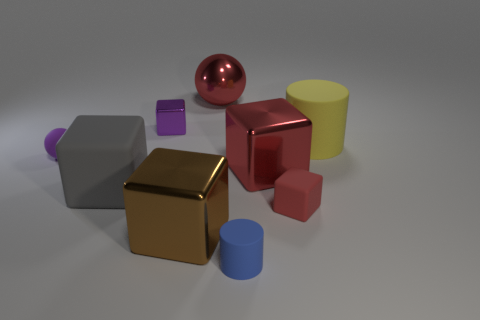Subtract all purple cubes. How many cubes are left? 4 Subtract all gray blocks. How many blocks are left? 4 Subtract all cyan cubes. Subtract all cyan spheres. How many cubes are left? 5 Subtract all balls. How many objects are left? 7 Subtract 0 cyan cylinders. How many objects are left? 9 Subtract all large gray objects. Subtract all big red objects. How many objects are left? 6 Add 4 large red metallic balls. How many large red metallic balls are left? 5 Add 1 large brown blocks. How many large brown blocks exist? 2 